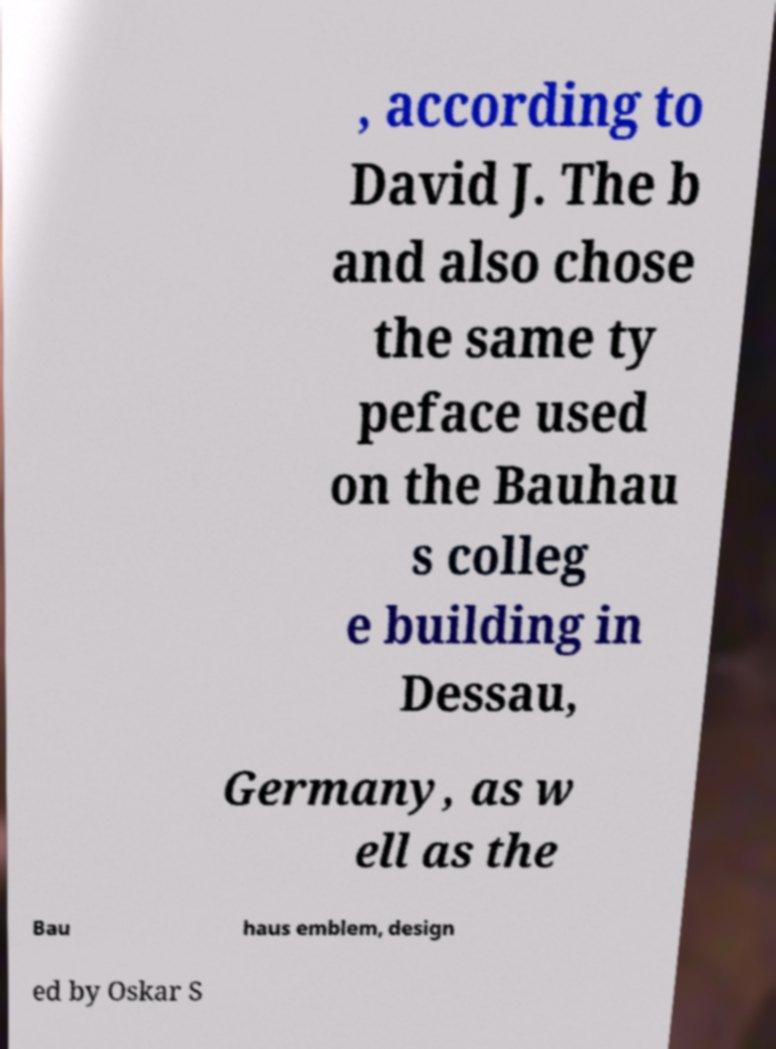Can you read and provide the text displayed in the image?This photo seems to have some interesting text. Can you extract and type it out for me? , according to David J. The b and also chose the same ty peface used on the Bauhau s colleg e building in Dessau, Germany, as w ell as the Bau haus emblem, design ed by Oskar S 